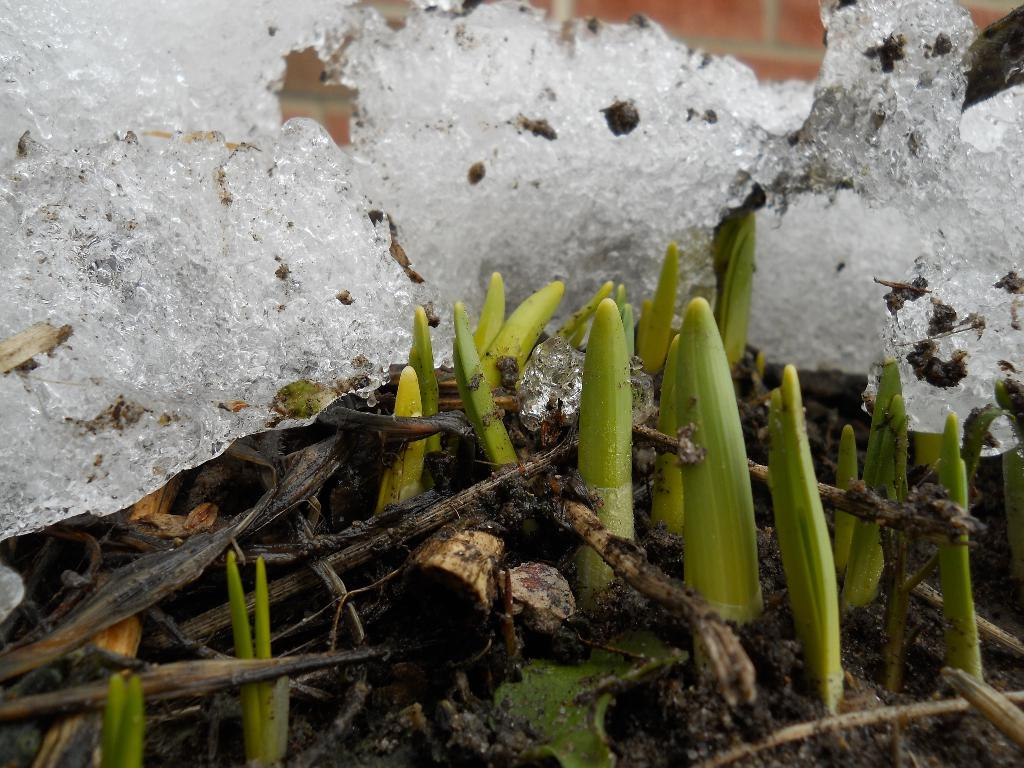What is one of the main features in the image? There is a wall in the image. What type of living organisms can be seen in the image? There are plants in the image. What is the unusual element present in the image? There is ice visible in the image. What is the reason for the sidewalk being present in the image? There is no sidewalk present in the image; it only features a wall, plants, and ice. 